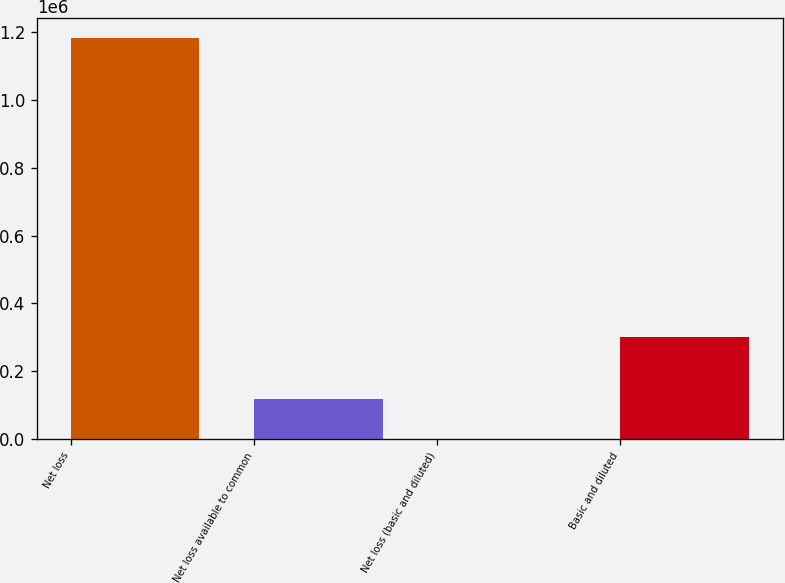Convert chart. <chart><loc_0><loc_0><loc_500><loc_500><bar_chart><fcel>Net loss<fcel>Net loss available to common<fcel>Net loss (basic and diluted)<fcel>Basic and diluted<nl><fcel>1.18257e+06<fcel>118260<fcel>3.94<fcel>300179<nl></chart> 